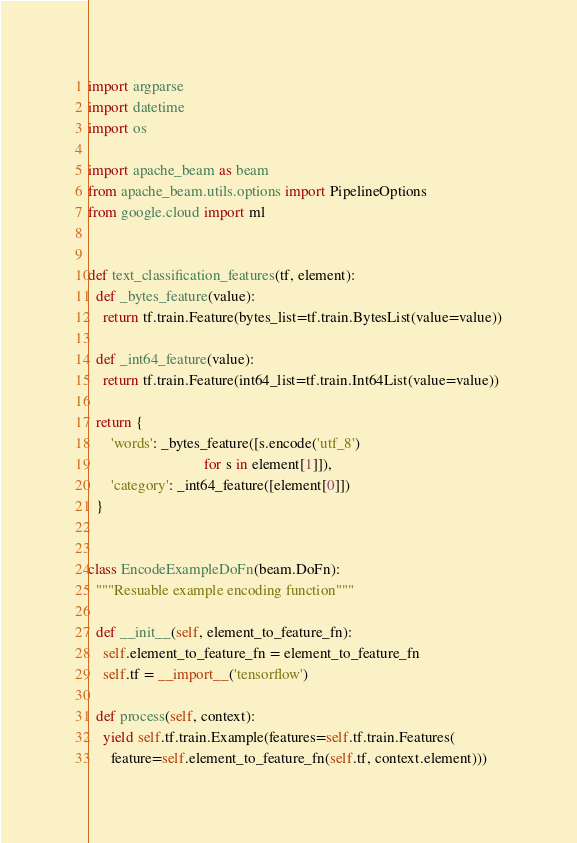Convert code to text. <code><loc_0><loc_0><loc_500><loc_500><_Python_>import argparse
import datetime
import os

import apache_beam as beam
from apache_beam.utils.options import PipelineOptions
from google.cloud import ml


def text_classification_features(tf, element):
  def _bytes_feature(value):
    return tf.train.Feature(bytes_list=tf.train.BytesList(value=value))

  def _int64_feature(value):
    return tf.train.Feature(int64_list=tf.train.Int64List(value=value))

  return {
      'words': _bytes_feature([s.encode('utf_8')
                               for s in element[1]]),
      'category': _int64_feature([element[0]])
  }


class EncodeExampleDoFn(beam.DoFn):
  """Resuable example encoding function"""

  def __init__(self, element_to_feature_fn):
    self.element_to_feature_fn = element_to_feature_fn
    self.tf = __import__('tensorflow')

  def process(self, context):
    yield self.tf.train.Example(features=self.tf.train.Features(
      feature=self.element_to_feature_fn(self.tf, context.element)))

</code> 